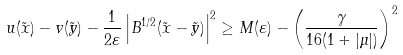<formula> <loc_0><loc_0><loc_500><loc_500>u ( \tilde { x } ) - v ( \tilde { y } ) - \frac { 1 } { 2 \varepsilon } \left | B ^ { 1 / 2 } ( \tilde { x } - \tilde { y } ) \right | ^ { 2 } \geq M ( \varepsilon ) - \left ( \frac { \gamma } { 1 6 ( 1 + | \mu | ) } \right ) ^ { 2 }</formula> 